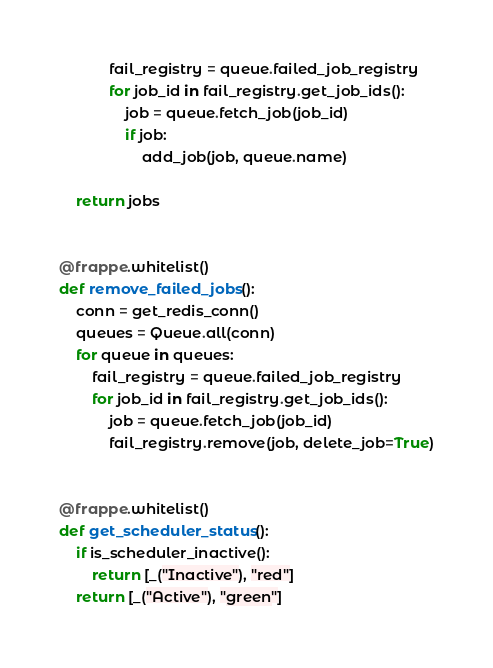<code> <loc_0><loc_0><loc_500><loc_500><_Python_>			fail_registry = queue.failed_job_registry
			for job_id in fail_registry.get_job_ids():
				job = queue.fetch_job(job_id)
				if job:
					add_job(job, queue.name)

	return jobs


@frappe.whitelist()
def remove_failed_jobs():
	conn = get_redis_conn()
	queues = Queue.all(conn)
	for queue in queues:
		fail_registry = queue.failed_job_registry
		for job_id in fail_registry.get_job_ids():
			job = queue.fetch_job(job_id)
			fail_registry.remove(job, delete_job=True)


@frappe.whitelist()
def get_scheduler_status():
	if is_scheduler_inactive():
		return [_("Inactive"), "red"]
	return [_("Active"), "green"]
</code> 